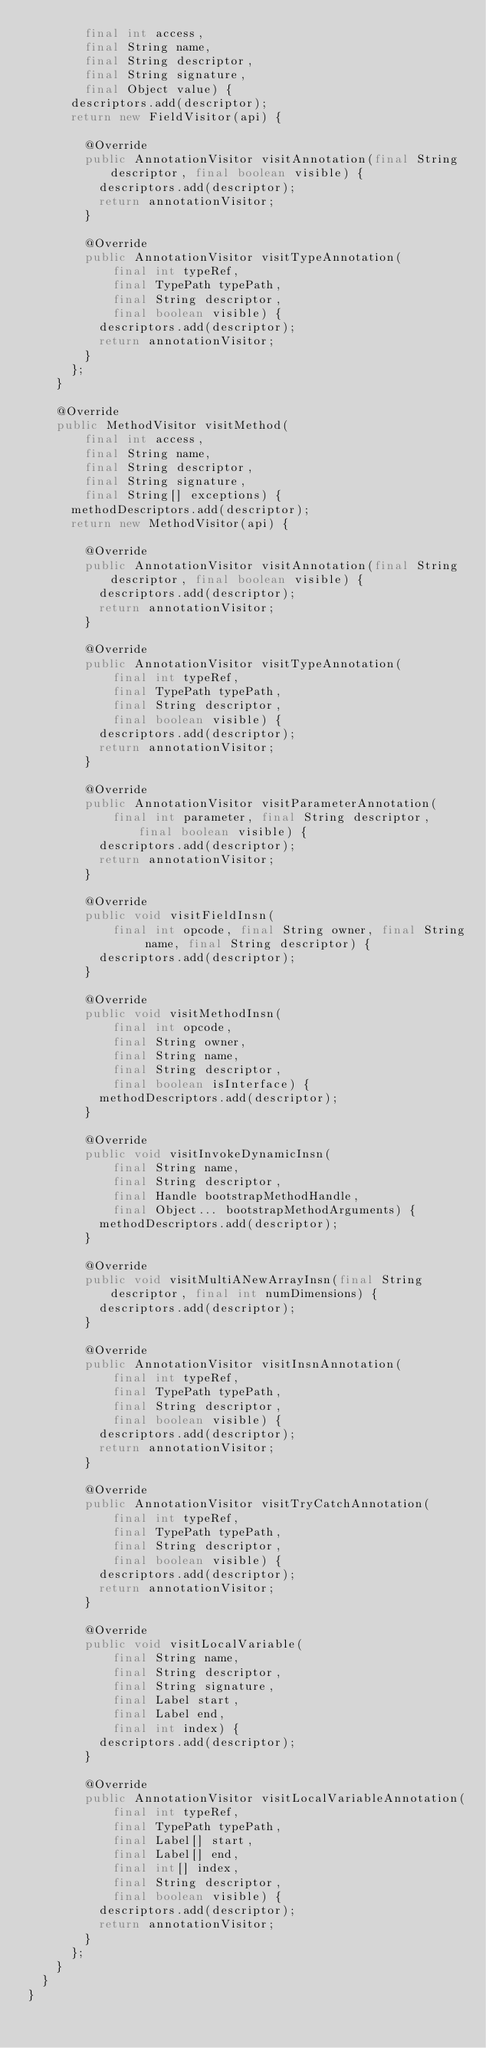Convert code to text. <code><loc_0><loc_0><loc_500><loc_500><_Java_>        final int access,
        final String name,
        final String descriptor,
        final String signature,
        final Object value) {
      descriptors.add(descriptor);
      return new FieldVisitor(api) {

        @Override
        public AnnotationVisitor visitAnnotation(final String descriptor, final boolean visible) {
          descriptors.add(descriptor);
          return annotationVisitor;
        }

        @Override
        public AnnotationVisitor visitTypeAnnotation(
            final int typeRef,
            final TypePath typePath,
            final String descriptor,
            final boolean visible) {
          descriptors.add(descriptor);
          return annotationVisitor;
        }
      };
    }

    @Override
    public MethodVisitor visitMethod(
        final int access,
        final String name,
        final String descriptor,
        final String signature,
        final String[] exceptions) {
      methodDescriptors.add(descriptor);
      return new MethodVisitor(api) {

        @Override
        public AnnotationVisitor visitAnnotation(final String descriptor, final boolean visible) {
          descriptors.add(descriptor);
          return annotationVisitor;
        }

        @Override
        public AnnotationVisitor visitTypeAnnotation(
            final int typeRef,
            final TypePath typePath,
            final String descriptor,
            final boolean visible) {
          descriptors.add(descriptor);
          return annotationVisitor;
        }

        @Override
        public AnnotationVisitor visitParameterAnnotation(
            final int parameter, final String descriptor, final boolean visible) {
          descriptors.add(descriptor);
          return annotationVisitor;
        }

        @Override
        public void visitFieldInsn(
            final int opcode, final String owner, final String name, final String descriptor) {
          descriptors.add(descriptor);
        }

        @Override
        public void visitMethodInsn(
            final int opcode,
            final String owner,
            final String name,
            final String descriptor,
            final boolean isInterface) {
          methodDescriptors.add(descriptor);
        }

        @Override
        public void visitInvokeDynamicInsn(
            final String name,
            final String descriptor,
            final Handle bootstrapMethodHandle,
            final Object... bootstrapMethodArguments) {
          methodDescriptors.add(descriptor);
        }

        @Override
        public void visitMultiANewArrayInsn(final String descriptor, final int numDimensions) {
          descriptors.add(descriptor);
        }

        @Override
        public AnnotationVisitor visitInsnAnnotation(
            final int typeRef,
            final TypePath typePath,
            final String descriptor,
            final boolean visible) {
          descriptors.add(descriptor);
          return annotationVisitor;
        }

        @Override
        public AnnotationVisitor visitTryCatchAnnotation(
            final int typeRef,
            final TypePath typePath,
            final String descriptor,
            final boolean visible) {
          descriptors.add(descriptor);
          return annotationVisitor;
        }

        @Override
        public void visitLocalVariable(
            final String name,
            final String descriptor,
            final String signature,
            final Label start,
            final Label end,
            final int index) {
          descriptors.add(descriptor);
        }

        @Override
        public AnnotationVisitor visitLocalVariableAnnotation(
            final int typeRef,
            final TypePath typePath,
            final Label[] start,
            final Label[] end,
            final int[] index,
            final String descriptor,
            final boolean visible) {
          descriptors.add(descriptor);
          return annotationVisitor;
        }
      };
    }
  }
}
</code> 